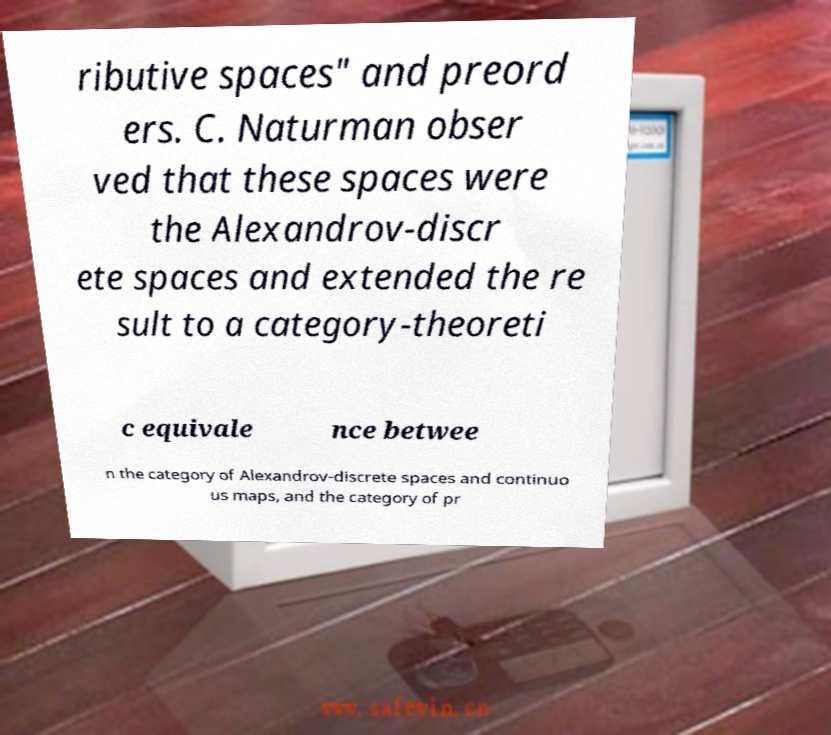I need the written content from this picture converted into text. Can you do that? ributive spaces" and preord ers. C. Naturman obser ved that these spaces were the Alexandrov-discr ete spaces and extended the re sult to a category-theoreti c equivale nce betwee n the category of Alexandrov-discrete spaces and continuo us maps, and the category of pr 